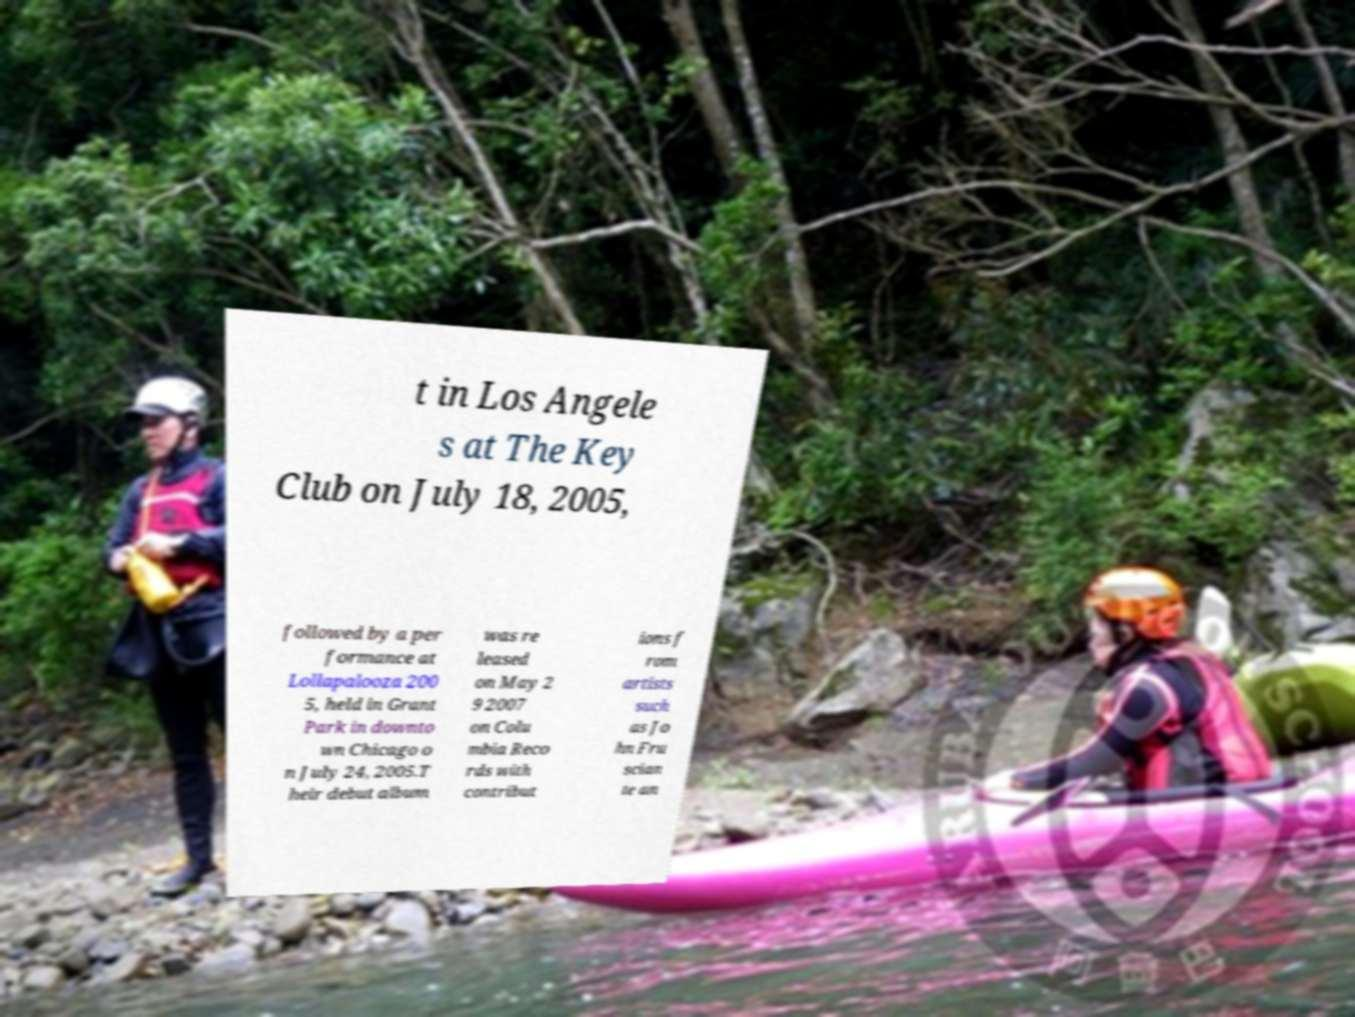There's text embedded in this image that I need extracted. Can you transcribe it verbatim? t in Los Angele s at The Key Club on July 18, 2005, followed by a per formance at Lollapalooza 200 5, held in Grant Park in downto wn Chicago o n July 24, 2005.T heir debut album was re leased on May 2 9 2007 on Colu mbia Reco rds with contribut ions f rom artists such as Jo hn Fru scian te an 